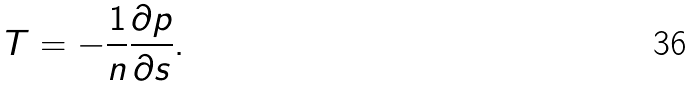Convert formula to latex. <formula><loc_0><loc_0><loc_500><loc_500>T = - \frac { 1 } { n } \frac { \partial p } { \partial s } .</formula> 